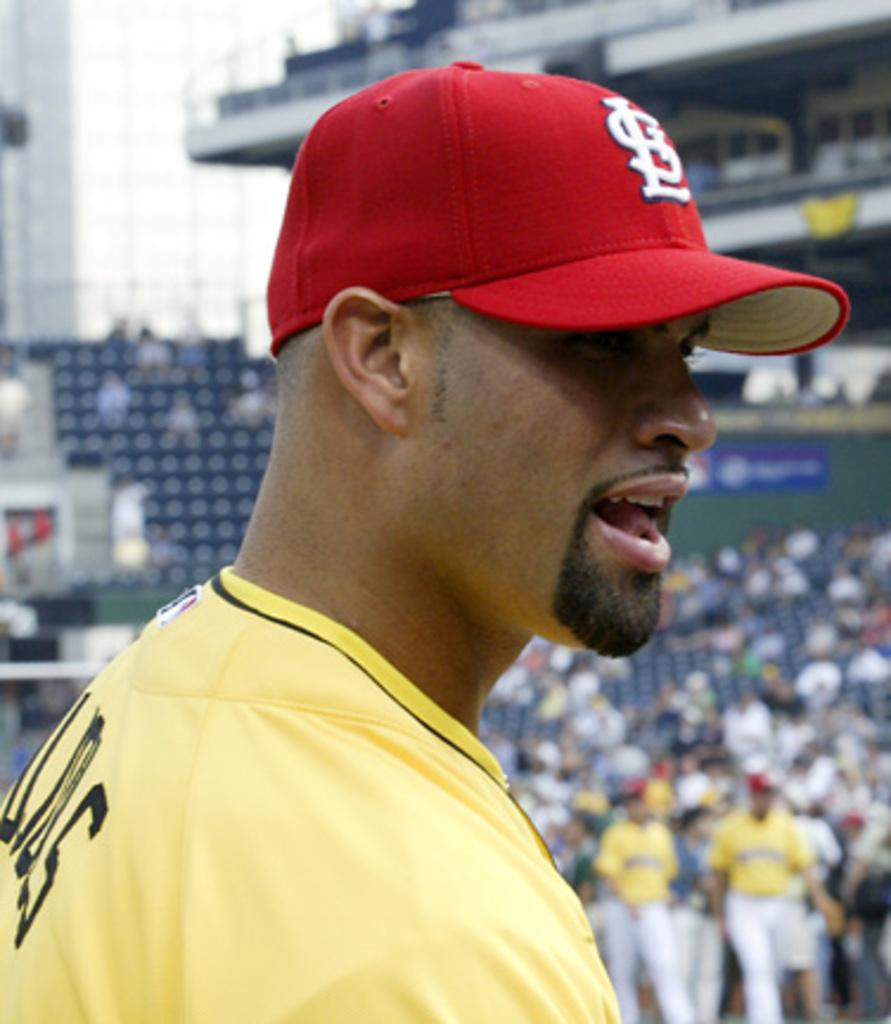<image>
Give a short and clear explanation of the subsequent image. A man wears a red hat with the letters SL on it. 